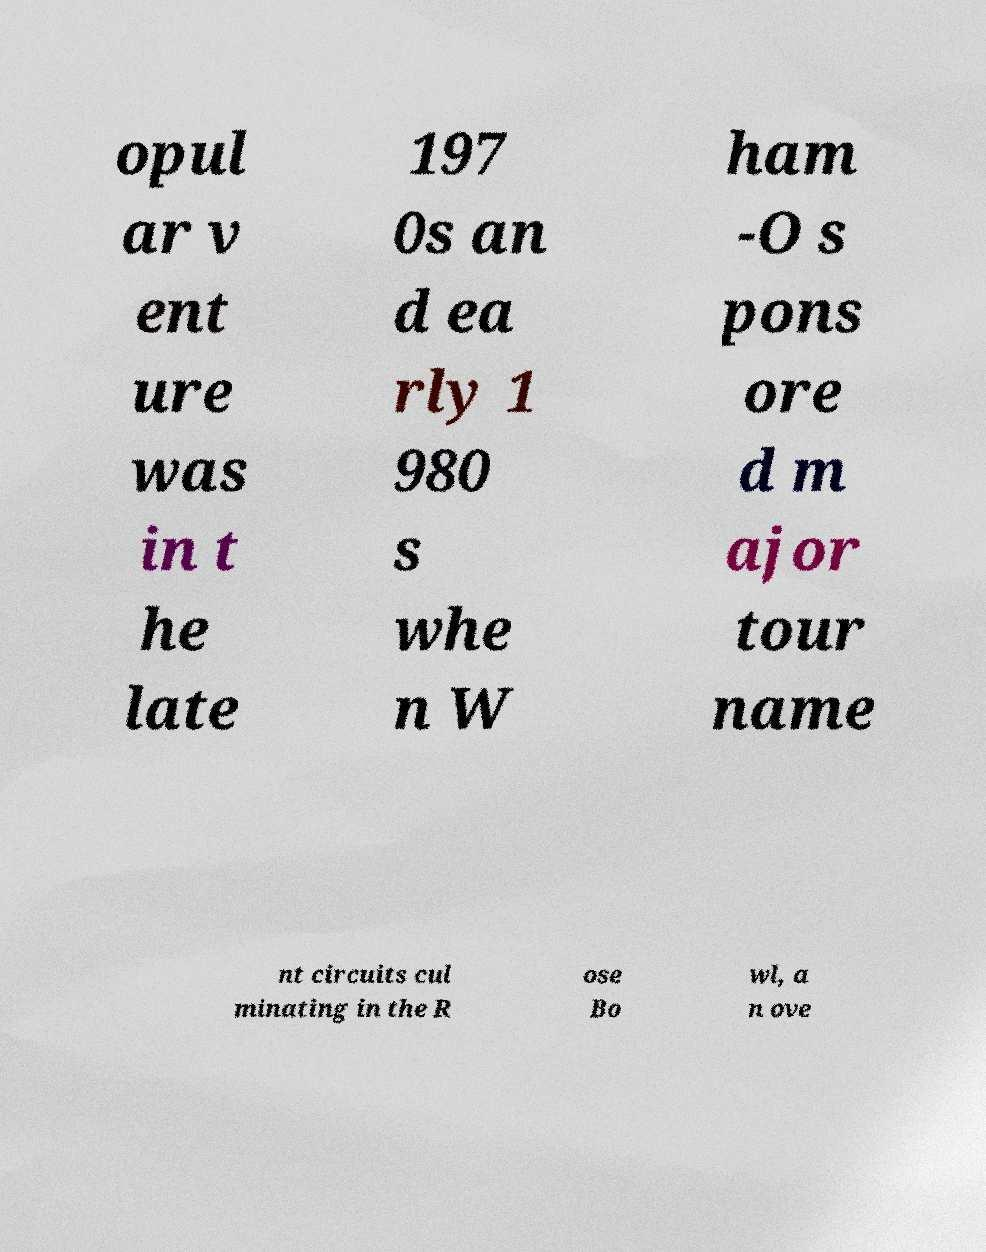Please identify and transcribe the text found in this image. opul ar v ent ure was in t he late 197 0s an d ea rly 1 980 s whe n W ham -O s pons ore d m ajor tour name nt circuits cul minating in the R ose Bo wl, a n ove 